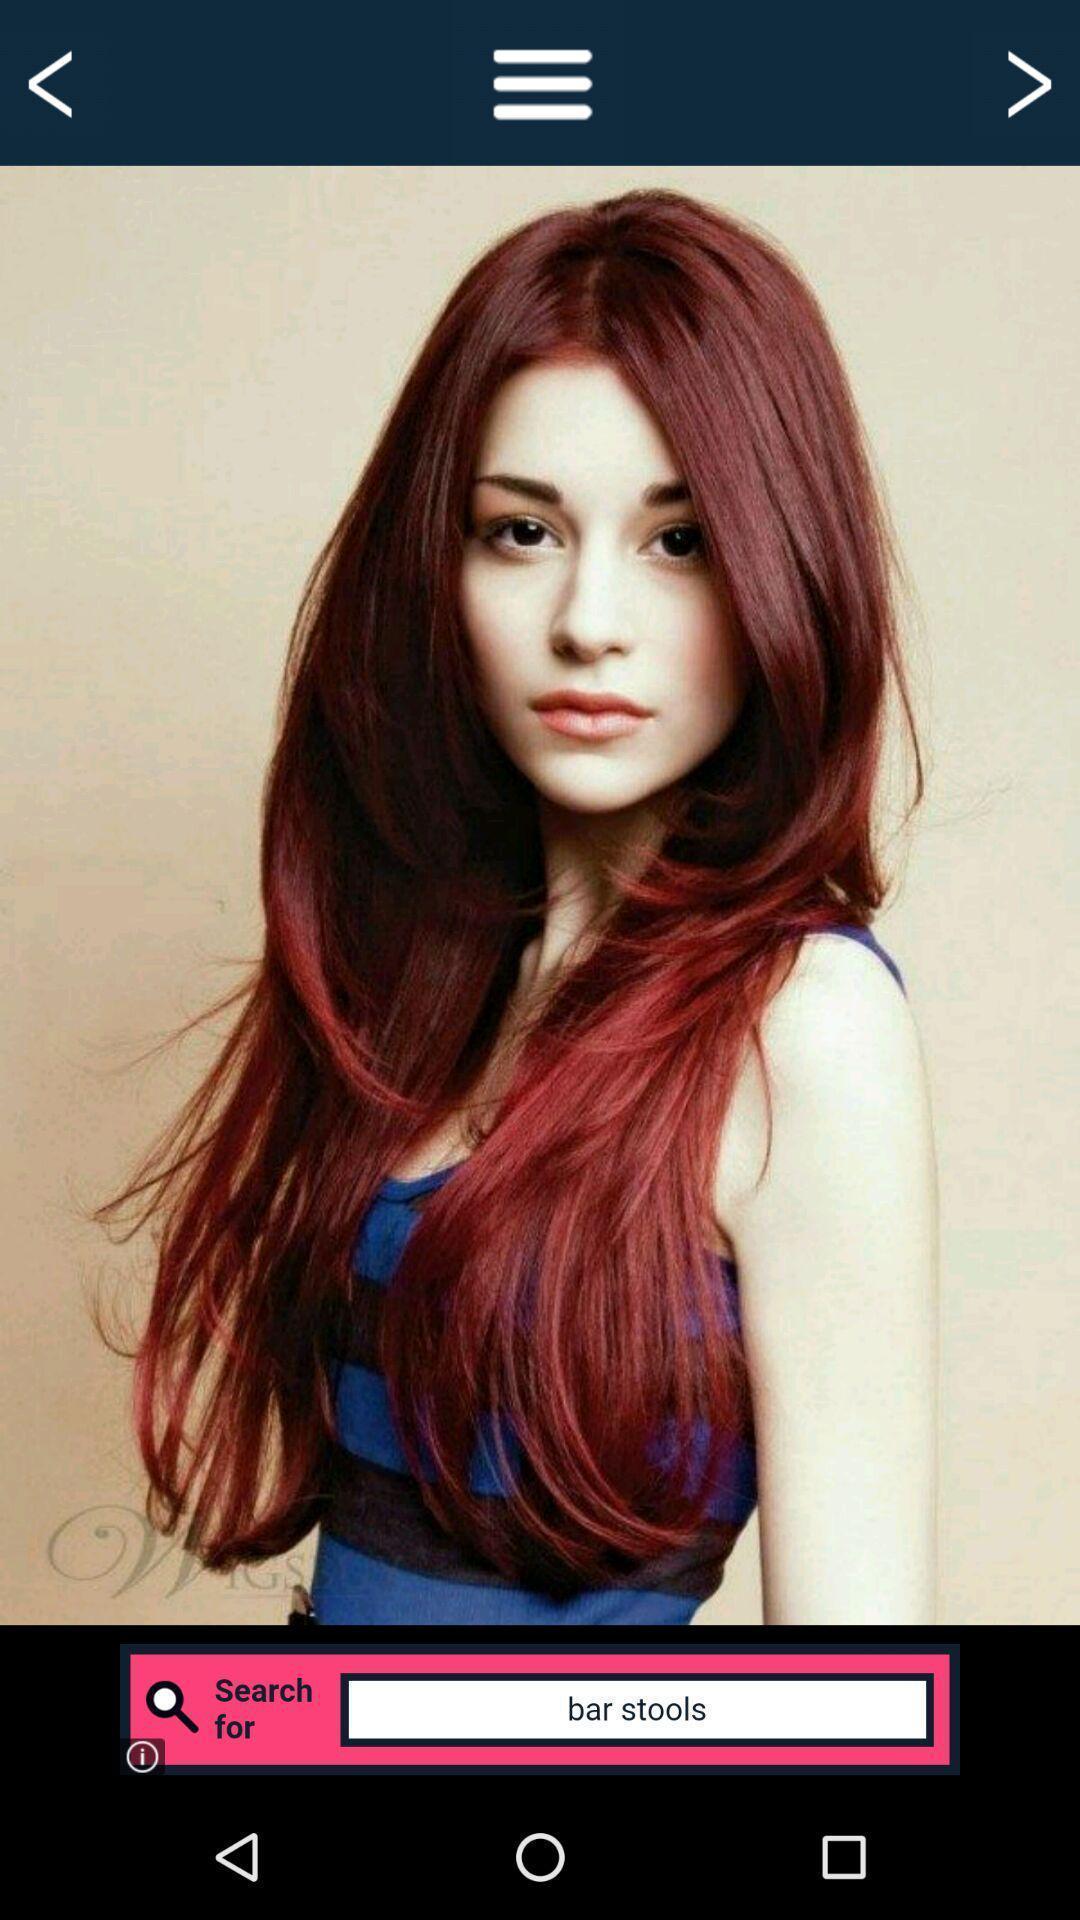Explain the elements present in this screenshot. Page displaying the girl image with search a bar. 